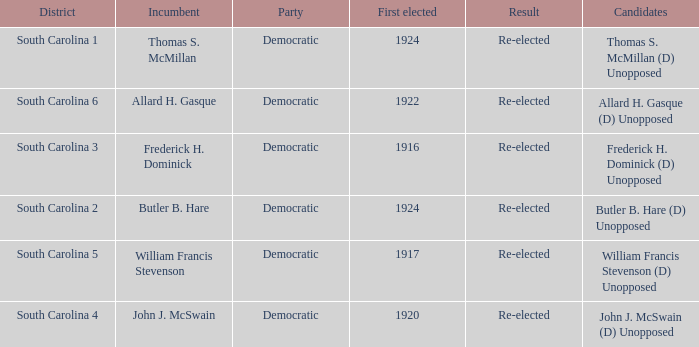What is the party for south carolina 3? Democratic. 